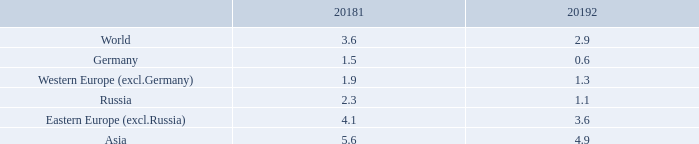DEVELOPMENT OF GROSS DOMESTIC PRODUCT IN IMPORTANT WORLD REGIONS AND GERMANY
Year-on-year change in %
Real GDP growth corrected for purchasing power. Source: Oxford Economics
1 The previous year’s figures may slightly deviate from the Annual Report 2017/18, since retrospective corrections are being made by the data provider.
2 Outlook.
Why might the figures in this annual report deviate slightly from last year? Since retrospective corrections are being made by the data provider. What is the year-on-year change in GDP in Asia in 2019?
Answer scale should be: percent. 4.9. Which regions in the table are listed in the analysis of GDP? World, germany, western europe (excl.germany), russia, eastern europe (excl.russia), asia. In which year was the Year-on-year percentage change of GDP in Asia larger from 2018 to 2019? 5.6>4.9
Answer: 2018. What was the change in the year-on-year percentage change in GDP for Russia from 2018 to 2019?
Answer scale should be: percent. 1.1-2.3
Answer: -1.2. What was the change in the year-on-year percentage change in GDP for Germany from 2018 to 2019?
Answer scale should be: percent. 0.6-1.5
Answer: -0.9. 